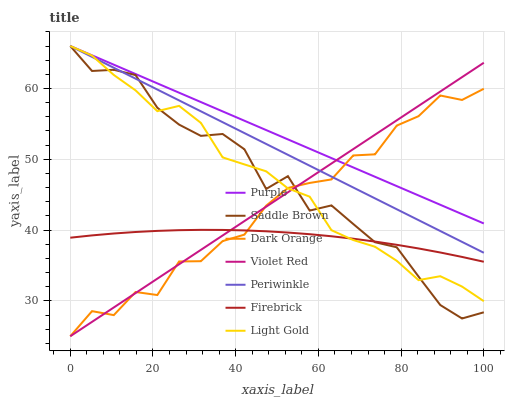Does Firebrick have the minimum area under the curve?
Answer yes or no. Yes. Does Purple have the maximum area under the curve?
Answer yes or no. Yes. Does Violet Red have the minimum area under the curve?
Answer yes or no. No. Does Violet Red have the maximum area under the curve?
Answer yes or no. No. Is Purple the smoothest?
Answer yes or no. Yes. Is Dark Orange the roughest?
Answer yes or no. Yes. Is Violet Red the smoothest?
Answer yes or no. No. Is Violet Red the roughest?
Answer yes or no. No. Does Dark Orange have the lowest value?
Answer yes or no. Yes. Does Purple have the lowest value?
Answer yes or no. No. Does Saddle Brown have the highest value?
Answer yes or no. Yes. Does Violet Red have the highest value?
Answer yes or no. No. Is Firebrick less than Purple?
Answer yes or no. Yes. Is Purple greater than Firebrick?
Answer yes or no. Yes. Does Firebrick intersect Violet Red?
Answer yes or no. Yes. Is Firebrick less than Violet Red?
Answer yes or no. No. Is Firebrick greater than Violet Red?
Answer yes or no. No. Does Firebrick intersect Purple?
Answer yes or no. No. 